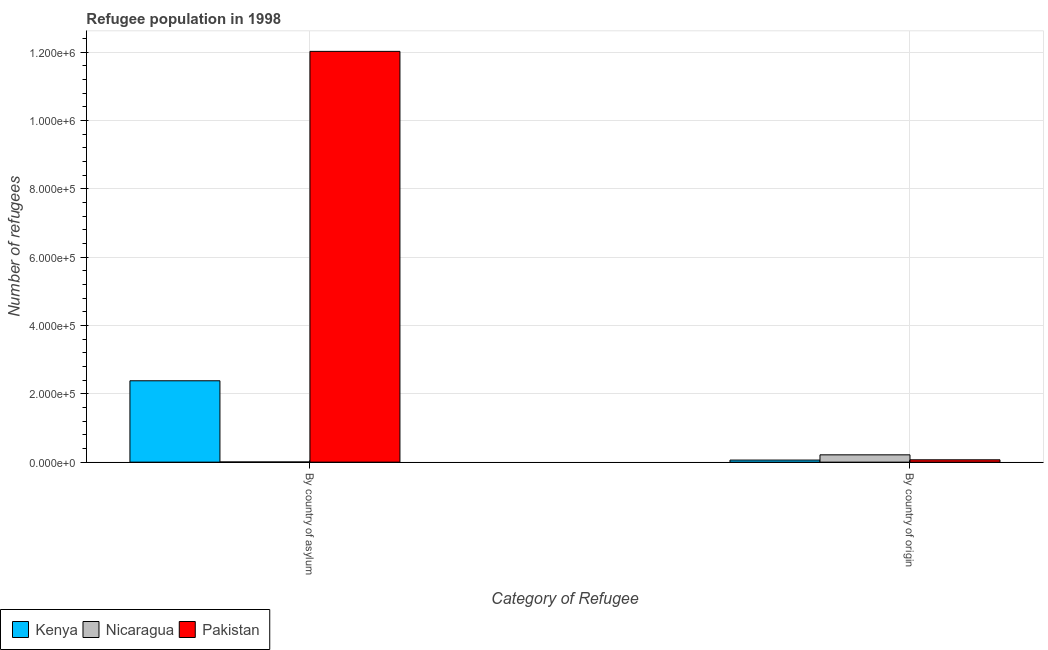How many different coloured bars are there?
Offer a terse response. 3. How many groups of bars are there?
Ensure brevity in your answer.  2. Are the number of bars per tick equal to the number of legend labels?
Give a very brief answer. Yes. Are the number of bars on each tick of the X-axis equal?
Your response must be concise. Yes. What is the label of the 2nd group of bars from the left?
Provide a succinct answer. By country of origin. What is the number of refugees by country of origin in Nicaragua?
Your response must be concise. 2.14e+04. Across all countries, what is the maximum number of refugees by country of origin?
Your response must be concise. 2.14e+04. Across all countries, what is the minimum number of refugees by country of origin?
Keep it short and to the point. 6046. In which country was the number of refugees by country of origin maximum?
Make the answer very short. Nicaragua. In which country was the number of refugees by country of origin minimum?
Offer a very short reply. Kenya. What is the total number of refugees by country of origin in the graph?
Provide a short and direct response. 3.43e+04. What is the difference between the number of refugees by country of origin in Nicaragua and that in Pakistan?
Your answer should be very brief. 1.45e+04. What is the difference between the number of refugees by country of asylum in Kenya and the number of refugees by country of origin in Nicaragua?
Make the answer very short. 2.17e+05. What is the average number of refugees by country of asylum per country?
Your answer should be compact. 4.80e+05. What is the difference between the number of refugees by country of origin and number of refugees by country of asylum in Nicaragua?
Keep it short and to the point. 2.09e+04. What is the ratio of the number of refugees by country of origin in Kenya to that in Nicaragua?
Offer a terse response. 0.28. In how many countries, is the number of refugees by country of asylum greater than the average number of refugees by country of asylum taken over all countries?
Provide a short and direct response. 1. What does the 1st bar from the left in By country of asylum represents?
Offer a terse response. Kenya. What does the 3rd bar from the right in By country of origin represents?
Offer a terse response. Kenya. Are all the bars in the graph horizontal?
Ensure brevity in your answer.  No. Does the graph contain any zero values?
Offer a very short reply. No. Does the graph contain grids?
Provide a succinct answer. Yes. What is the title of the graph?
Offer a very short reply. Refugee population in 1998. What is the label or title of the X-axis?
Your answer should be very brief. Category of Refugee. What is the label or title of the Y-axis?
Offer a very short reply. Number of refugees. What is the Number of refugees of Kenya in By country of asylum?
Provide a succinct answer. 2.38e+05. What is the Number of refugees in Nicaragua in By country of asylum?
Your answer should be very brief. 474. What is the Number of refugees of Pakistan in By country of asylum?
Your response must be concise. 1.20e+06. What is the Number of refugees in Kenya in By country of origin?
Your answer should be very brief. 6046. What is the Number of refugees in Nicaragua in By country of origin?
Your answer should be compact. 2.14e+04. What is the Number of refugees in Pakistan in By country of origin?
Offer a very short reply. 6864. Across all Category of Refugee, what is the maximum Number of refugees in Kenya?
Ensure brevity in your answer.  2.38e+05. Across all Category of Refugee, what is the maximum Number of refugees in Nicaragua?
Give a very brief answer. 2.14e+04. Across all Category of Refugee, what is the maximum Number of refugees of Pakistan?
Provide a short and direct response. 1.20e+06. Across all Category of Refugee, what is the minimum Number of refugees in Kenya?
Offer a very short reply. 6046. Across all Category of Refugee, what is the minimum Number of refugees of Nicaragua?
Your response must be concise. 474. Across all Category of Refugee, what is the minimum Number of refugees of Pakistan?
Provide a short and direct response. 6864. What is the total Number of refugees of Kenya in the graph?
Keep it short and to the point. 2.44e+05. What is the total Number of refugees of Nicaragua in the graph?
Provide a short and direct response. 2.19e+04. What is the total Number of refugees in Pakistan in the graph?
Keep it short and to the point. 1.21e+06. What is the difference between the Number of refugees of Kenya in By country of asylum and that in By country of origin?
Your answer should be compact. 2.32e+05. What is the difference between the Number of refugees in Nicaragua in By country of asylum and that in By country of origin?
Your answer should be very brief. -2.09e+04. What is the difference between the Number of refugees of Pakistan in By country of asylum and that in By country of origin?
Ensure brevity in your answer.  1.20e+06. What is the difference between the Number of refugees in Kenya in By country of asylum and the Number of refugees in Nicaragua in By country of origin?
Ensure brevity in your answer.  2.17e+05. What is the difference between the Number of refugees in Kenya in By country of asylum and the Number of refugees in Pakistan in By country of origin?
Keep it short and to the point. 2.31e+05. What is the difference between the Number of refugees of Nicaragua in By country of asylum and the Number of refugees of Pakistan in By country of origin?
Ensure brevity in your answer.  -6390. What is the average Number of refugees of Kenya per Category of Refugee?
Provide a succinct answer. 1.22e+05. What is the average Number of refugees of Nicaragua per Category of Refugee?
Keep it short and to the point. 1.09e+04. What is the average Number of refugees of Pakistan per Category of Refugee?
Give a very brief answer. 6.05e+05. What is the difference between the Number of refugees in Kenya and Number of refugees in Nicaragua in By country of asylum?
Give a very brief answer. 2.38e+05. What is the difference between the Number of refugees in Kenya and Number of refugees in Pakistan in By country of asylum?
Keep it short and to the point. -9.64e+05. What is the difference between the Number of refugees in Nicaragua and Number of refugees in Pakistan in By country of asylum?
Your answer should be very brief. -1.20e+06. What is the difference between the Number of refugees in Kenya and Number of refugees in Nicaragua in By country of origin?
Ensure brevity in your answer.  -1.53e+04. What is the difference between the Number of refugees of Kenya and Number of refugees of Pakistan in By country of origin?
Your answer should be very brief. -818. What is the difference between the Number of refugees in Nicaragua and Number of refugees in Pakistan in By country of origin?
Keep it short and to the point. 1.45e+04. What is the ratio of the Number of refugees of Kenya in By country of asylum to that in By country of origin?
Your answer should be compact. 39.4. What is the ratio of the Number of refugees of Nicaragua in By country of asylum to that in By country of origin?
Offer a very short reply. 0.02. What is the ratio of the Number of refugees in Pakistan in By country of asylum to that in By country of origin?
Make the answer very short. 175.18. What is the difference between the highest and the second highest Number of refugees of Kenya?
Keep it short and to the point. 2.32e+05. What is the difference between the highest and the second highest Number of refugees in Nicaragua?
Your answer should be compact. 2.09e+04. What is the difference between the highest and the second highest Number of refugees in Pakistan?
Ensure brevity in your answer.  1.20e+06. What is the difference between the highest and the lowest Number of refugees of Kenya?
Your answer should be very brief. 2.32e+05. What is the difference between the highest and the lowest Number of refugees of Nicaragua?
Make the answer very short. 2.09e+04. What is the difference between the highest and the lowest Number of refugees in Pakistan?
Give a very brief answer. 1.20e+06. 